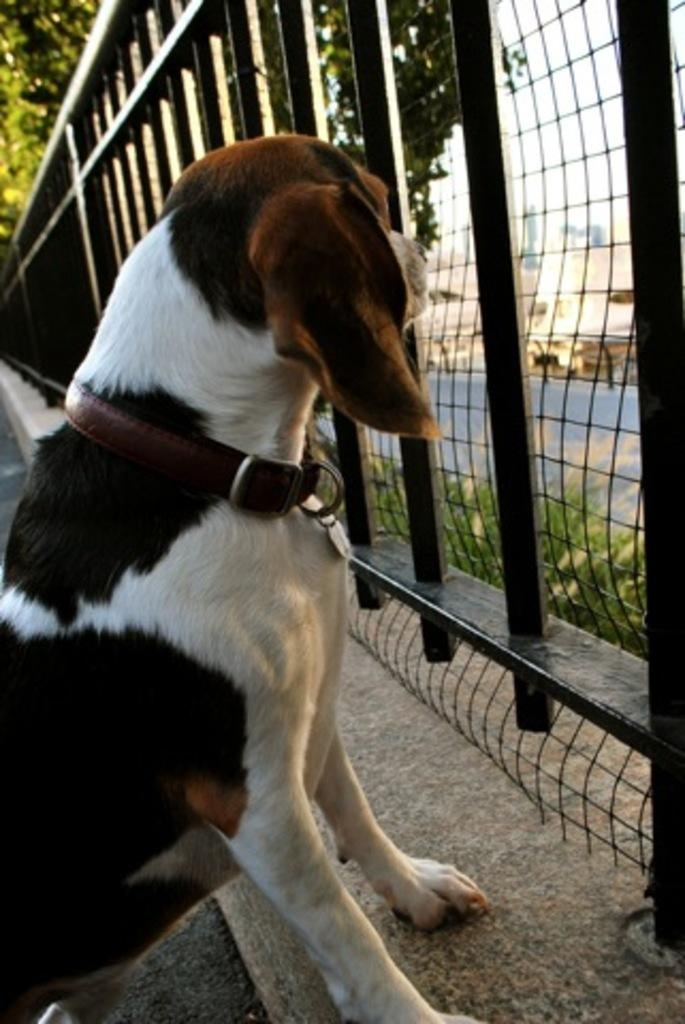What animal can be seen in the image? There is a dog in the image. What is the dog doing in the image? The dog is looking outside through a metal mesh fence. What can be seen on the other side of the fence? There is a road on the other side of the fence. What is visible behind the road? There are buildings behind the road. What type of vegetation is visible behind the buildings? There are trees visible behind the buildings. What type of advertisement can be seen on the dog's collar in the image? There is no advertisement on the dog's collar in the image; the dog is not wearing a collar. 